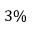Convert formula to latex. <formula><loc_0><loc_0><loc_500><loc_500>3 \%</formula> 